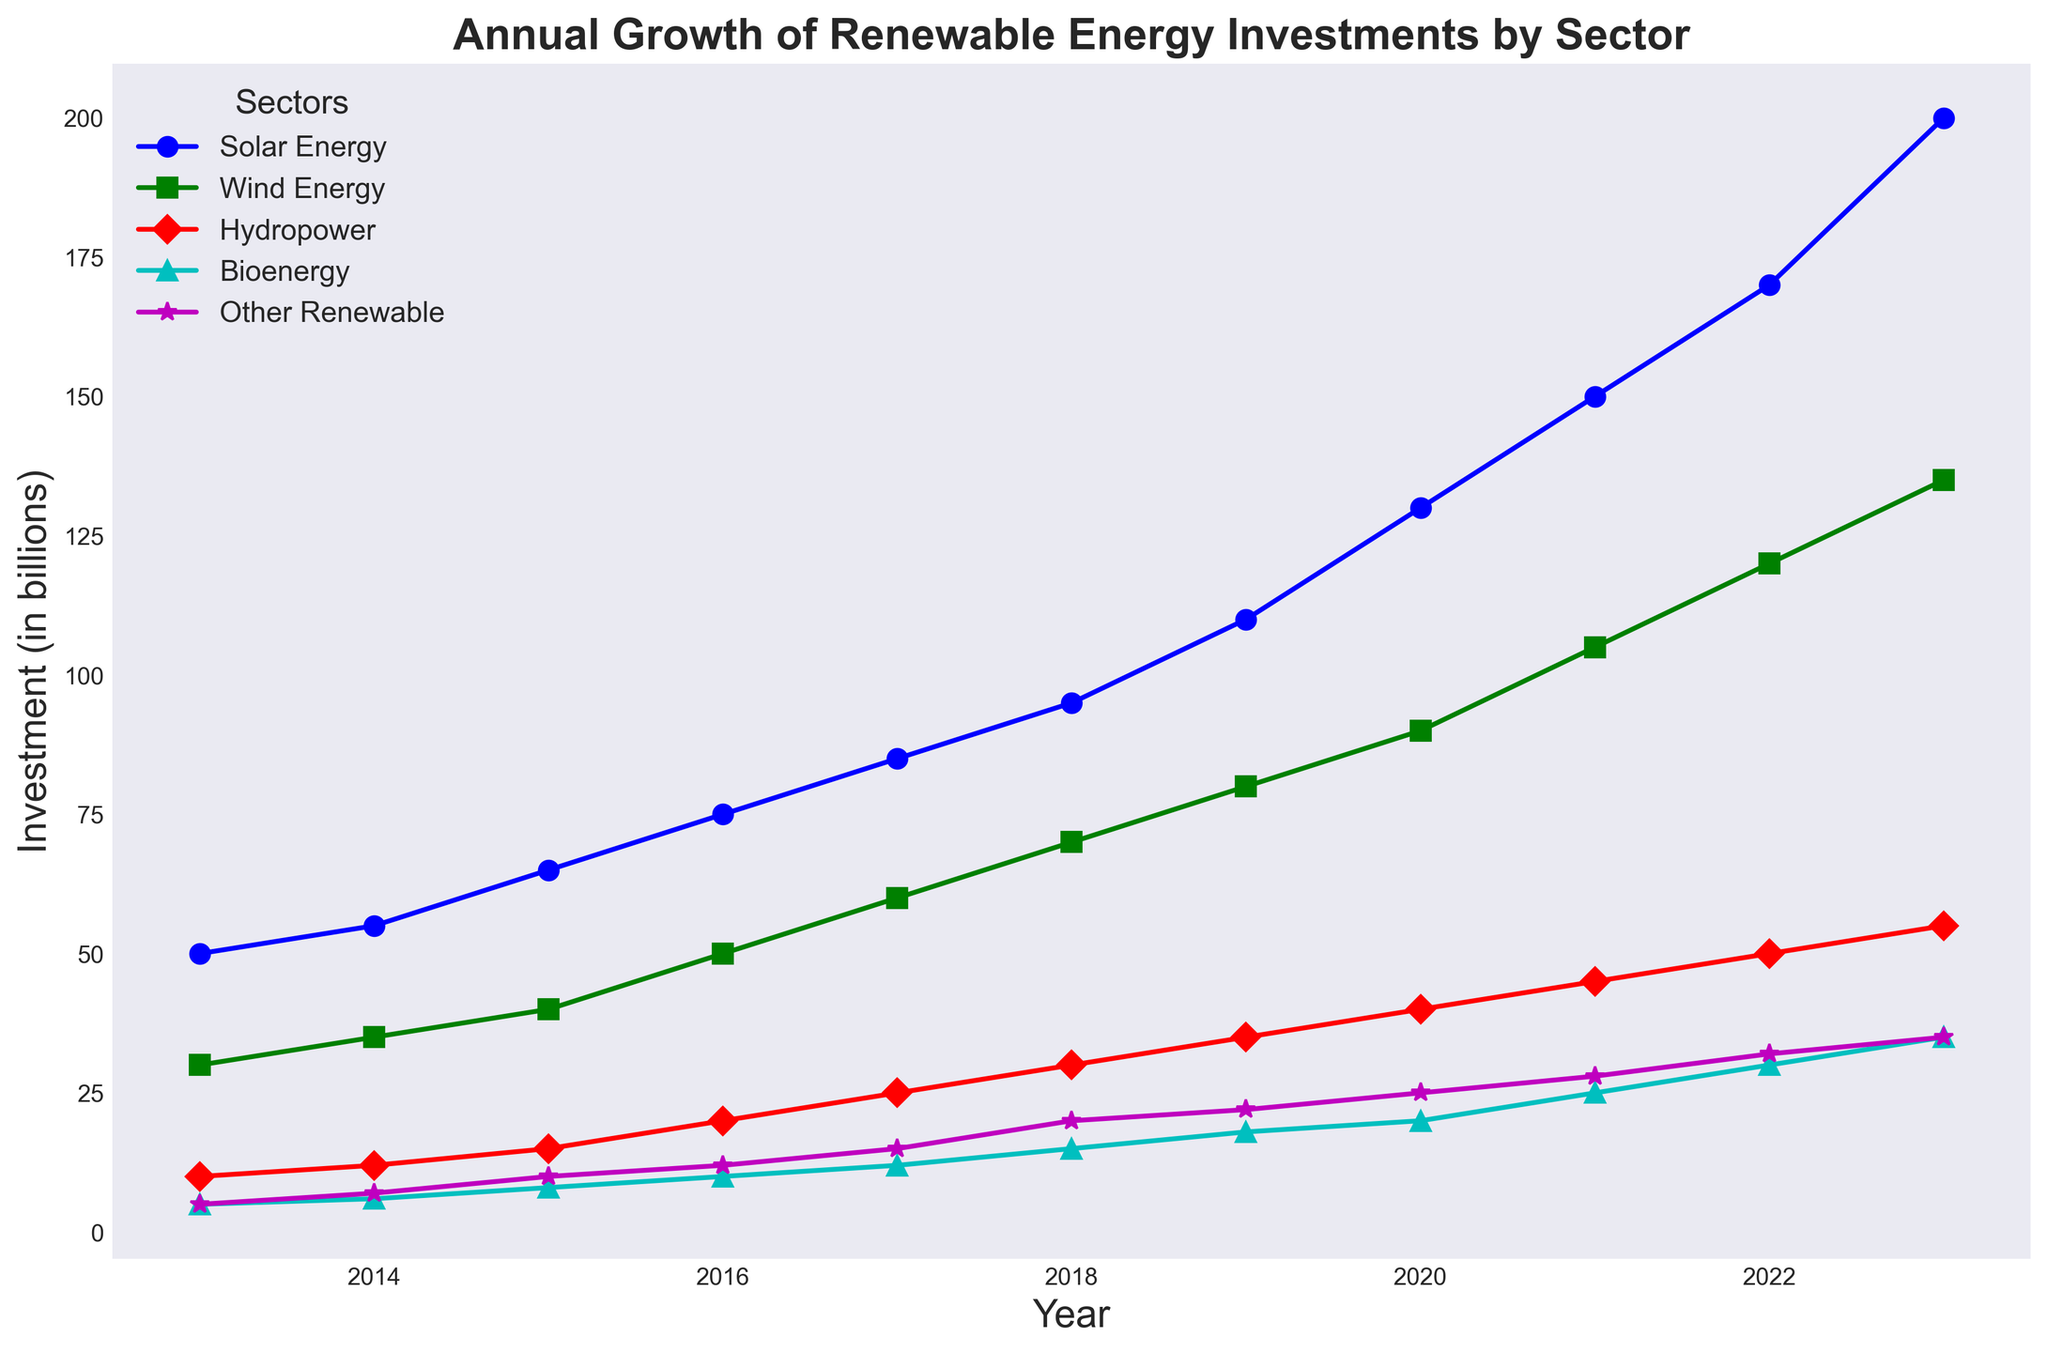What was the total investment in renewable energy sectors in 2020? Sum up the investments from all sectors for the year 2020: Solar Energy (130) + Wind Energy (90) + Hydropower (40) + Bioenergy (20) + Other Renewable (25). The total is 130 + 90 + 40 + 20 + 25 = 305 billions.
Answer: 305 billions Which sector had the highest growth in investments between 2015 and 2020? Calculate the difference in investments for each sector between 2015 and 2020: Solar Energy (130-65 = 65), Wind Energy (90-40 = 50), Hydropower (40-15 = 25), Bioenergy (20-8 = 12), Other Renewable (25-10 = 15). The highest growth is in Solar Energy with an increase of 65 billions.
Answer: Solar Energy In which year did Bioenergy investments first exceed 10 billion? Look at the Bioenergy line in the chart and note the years when investments surpassed 10 billion. Bioenergy investments first exceeded 10 billion in 2016 with an investment of 10 billion.
Answer: 2016 How does 2023's investment in Wind Energy compare to Solar Energy in 2019? Check the investment values for the specified years: Wind Energy in 2023 is 135 billion, and Solar Energy in 2019 is 110 billion. Compare these values: 135 billion is greater than 110 billion.
Answer: Wind Energy in 2023 is higher What was the average annual growth in Solar Energy investments from 2013 to 2023? Calculate the average increment per year by dividing the total growth by the number of years. From 2013 to 2023, the growth is 200 - 50 = 150 billion over 10 years. The average growth per year is 150 / 10 = 15 billion.
Answer: 15 billion Did Other Renewable investments ever surpass Hydropower investments? If yes, in which year? Compare the annual investments in Other Renewable and Hydropower sectors in the chart. From the chart, Other Renewable investments first surpassed Hydropower investments in 2019 (Other Renewable: 22 billion, Hydropower: 35 billion) and continue to do so afterward.
Answer: No Which sector had the least variability in investments over the decade? Observe the lines and determine the sector with the least fluctuation. Hydropower shows the least variability as its line has the most gentle slope over the years compared to the other sectors, with a relatively steady increase.
Answer: Hydropower What was the combined investment in Bioenergy and Other Renewable sectors in 2022? Add the values for Bioenergy (30 billion) and Other Renewable (32 billion) in 2022: 30 + 32 = 62 billion.
Answer: 62 billion How much did the investment in Wind Energy increase from 2013 to 2023? Subtract the Wind Energy investment in 2013 from that in 2023. For Wind Energy, the increase is 135 - 30 = 105 billion.
Answer: 105 billion Which year showed the highest overall increase in total investments across all sectors compared to the previous year? Calculate the year-on-year increase for each year and identify the highest. For each year:
2014: (55+35+12+6+7) - (50+30+10+5+5) = 115 - 100 = 15
2015: (65+40+15+8+10) - (55+35+12+6+7) = 138 - 115 = 23
2016: (75+50+20+10+12) - (65+40+15+8+10) = 167 - 138 = 29
2017: (85+60+25+12+15) - (75+50+20+10+12) = 197 - 167 = 30
2018: (95+70+30+15+20) - (85+60+25+12+15) = 230 - 197 = 33
2019: (110+80+35+18+22) - (95+70+30+15+20) = 265 - 230 = 35
2020: (130+90+40+20+25) - (110+80+35+18+22) = 305 - 265 = 40
2021: (150+105+45+25+28) - (130+90+40+20+25) = 353 - 305 = 48
2022: (170+120+50+30+32) - (150+105+45+25+28) = 402 - 353 = 49
2023: (200+135+55+35+35) - (170+120+50+30+32) = 460 - 402 = 58
The highest increase is in 2023, with a total increase of 58 billion.
Answer: 2023 